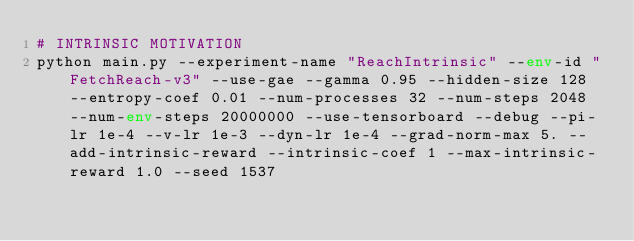<code> <loc_0><loc_0><loc_500><loc_500><_Bash_># INTRINSIC MOTIVATION
python main.py --experiment-name "ReachIntrinsic" --env-id "FetchReach-v3" --use-gae --gamma 0.95 --hidden-size 128 --entropy-coef 0.01 --num-processes 32 --num-steps 2048 --num-env-steps 20000000 --use-tensorboard --debug --pi-lr 1e-4 --v-lr 1e-3 --dyn-lr 1e-4 --grad-norm-max 5. --add-intrinsic-reward --intrinsic-coef 1 --max-intrinsic-reward 1.0 --seed 1537</code> 